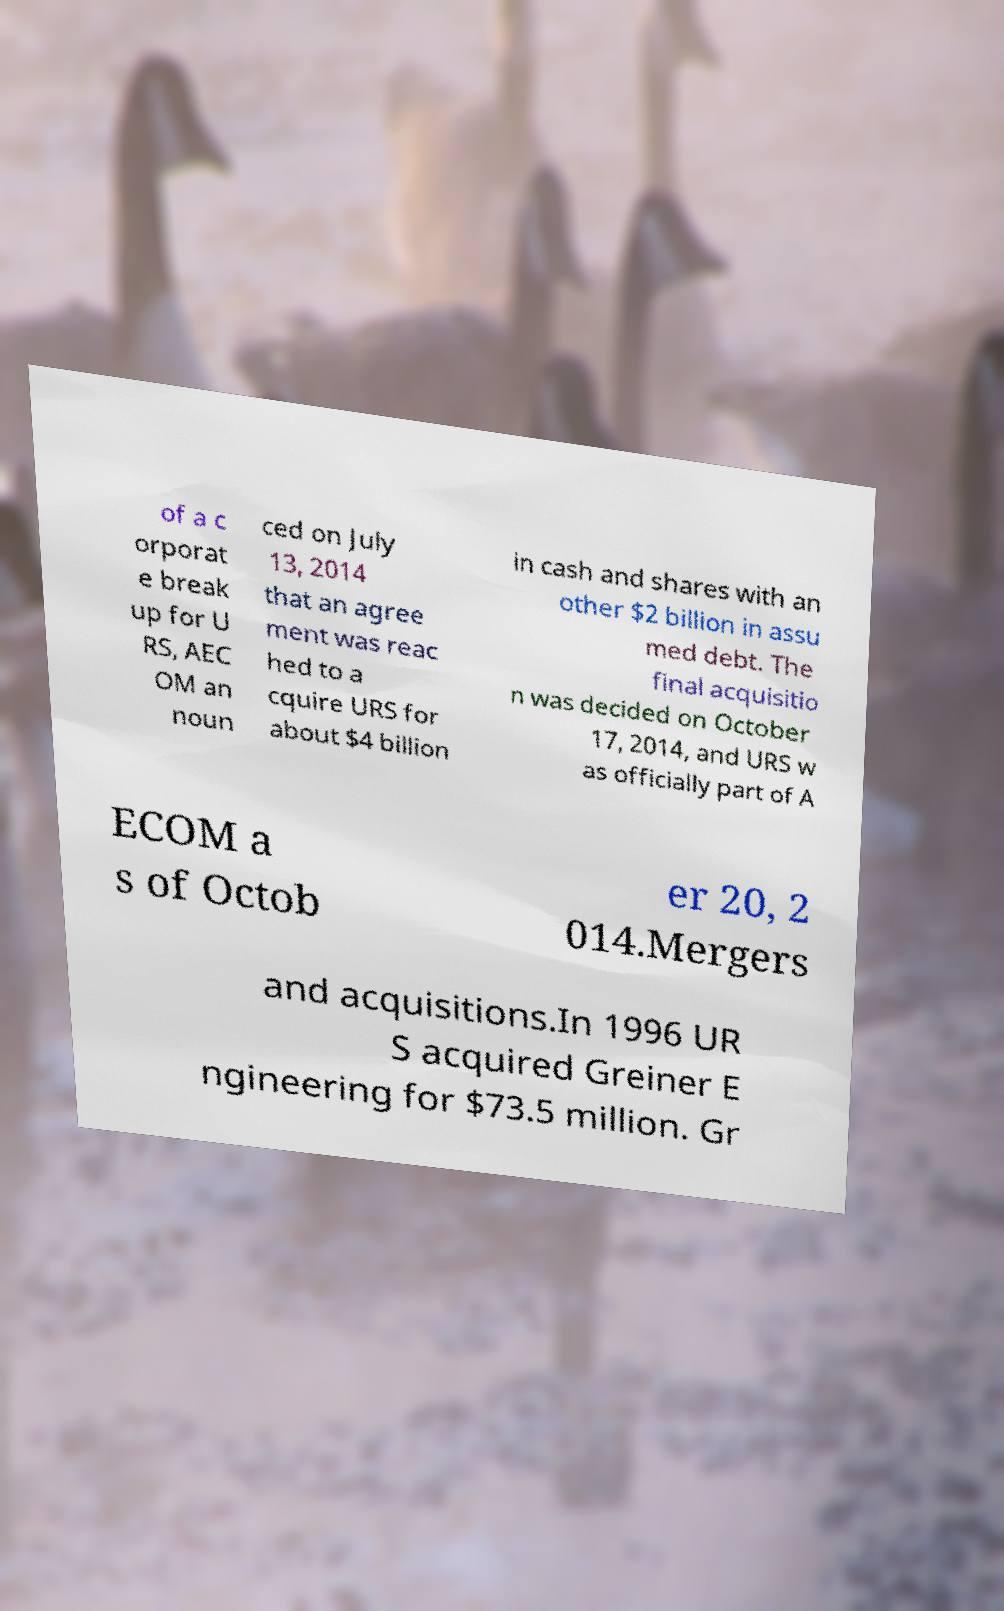For documentation purposes, I need the text within this image transcribed. Could you provide that? of a c orporat e break up for U RS, AEC OM an noun ced on July 13, 2014 that an agree ment was reac hed to a cquire URS for about $4 billion in cash and shares with an other $2 billion in assu med debt. The final acquisitio n was decided on October 17, 2014, and URS w as officially part of A ECOM a s of Octob er 20, 2 014.Mergers and acquisitions.In 1996 UR S acquired Greiner E ngineering for $73.5 million. Gr 